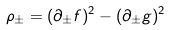<formula> <loc_0><loc_0><loc_500><loc_500>\rho _ { \pm } = ( \partial _ { \pm } f ) ^ { 2 } - ( \partial _ { \pm } g ) ^ { 2 }</formula> 